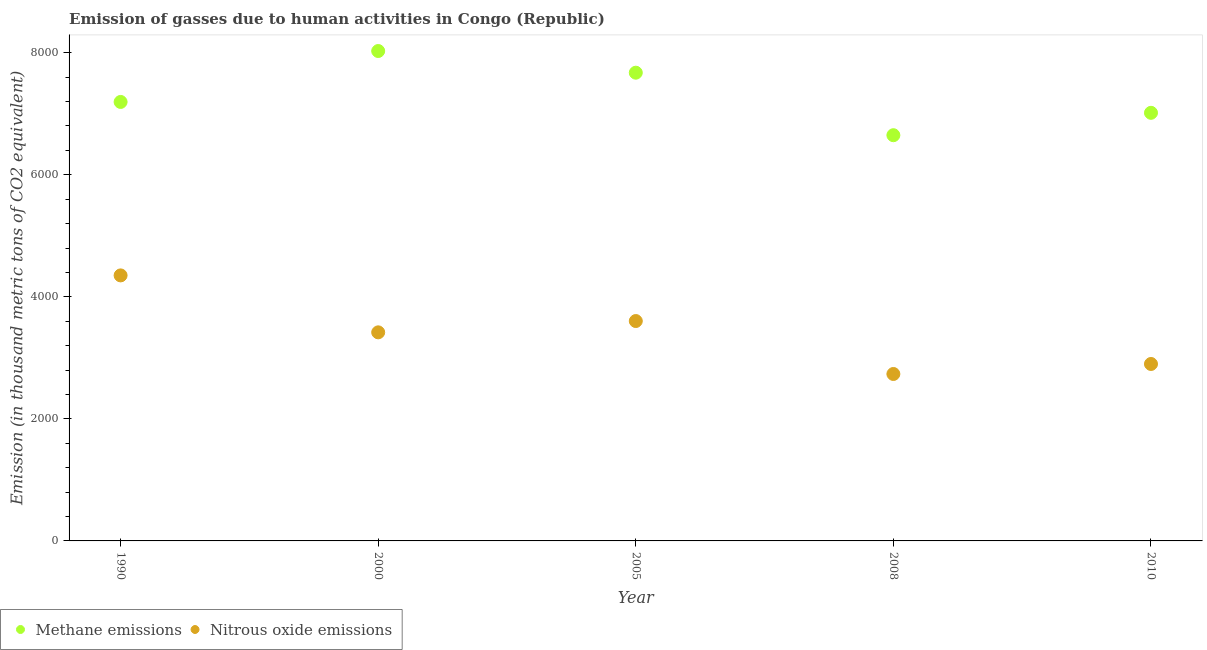How many different coloured dotlines are there?
Your answer should be very brief. 2. Is the number of dotlines equal to the number of legend labels?
Ensure brevity in your answer.  Yes. What is the amount of methane emissions in 2000?
Offer a very short reply. 8028.7. Across all years, what is the maximum amount of methane emissions?
Offer a terse response. 8028.7. Across all years, what is the minimum amount of methane emissions?
Your answer should be compact. 6649.1. In which year was the amount of methane emissions maximum?
Keep it short and to the point. 2000. What is the total amount of nitrous oxide emissions in the graph?
Provide a succinct answer. 1.70e+04. What is the difference between the amount of methane emissions in 2008 and that in 2010?
Provide a short and direct response. -366.9. What is the difference between the amount of nitrous oxide emissions in 2000 and the amount of methane emissions in 2008?
Offer a terse response. -3230.8. What is the average amount of nitrous oxide emissions per year?
Provide a short and direct response. 3401.78. In the year 2000, what is the difference between the amount of methane emissions and amount of nitrous oxide emissions?
Keep it short and to the point. 4610.4. What is the ratio of the amount of methane emissions in 2005 to that in 2010?
Your response must be concise. 1.09. Is the amount of methane emissions in 1990 less than that in 2005?
Provide a short and direct response. Yes. Is the difference between the amount of nitrous oxide emissions in 2008 and 2010 greater than the difference between the amount of methane emissions in 2008 and 2010?
Provide a succinct answer. Yes. What is the difference between the highest and the second highest amount of methane emissions?
Make the answer very short. 355.1. What is the difference between the highest and the lowest amount of nitrous oxide emissions?
Provide a short and direct response. 1615.7. Is the sum of the amount of nitrous oxide emissions in 2005 and 2008 greater than the maximum amount of methane emissions across all years?
Your answer should be very brief. No. Is the amount of methane emissions strictly less than the amount of nitrous oxide emissions over the years?
Provide a succinct answer. No. How many dotlines are there?
Your answer should be very brief. 2. Are the values on the major ticks of Y-axis written in scientific E-notation?
Offer a terse response. No. Does the graph contain any zero values?
Your answer should be compact. No. Does the graph contain grids?
Provide a succinct answer. No. Where does the legend appear in the graph?
Keep it short and to the point. Bottom left. How many legend labels are there?
Your answer should be compact. 2. What is the title of the graph?
Offer a very short reply. Emission of gasses due to human activities in Congo (Republic). Does "Exports of goods" appear as one of the legend labels in the graph?
Your response must be concise. No. What is the label or title of the Y-axis?
Offer a very short reply. Emission (in thousand metric tons of CO2 equivalent). What is the Emission (in thousand metric tons of CO2 equivalent) of Methane emissions in 1990?
Offer a terse response. 7194.2. What is the Emission (in thousand metric tons of CO2 equivalent) in Nitrous oxide emissions in 1990?
Provide a short and direct response. 4351.5. What is the Emission (in thousand metric tons of CO2 equivalent) in Methane emissions in 2000?
Give a very brief answer. 8028.7. What is the Emission (in thousand metric tons of CO2 equivalent) in Nitrous oxide emissions in 2000?
Your answer should be very brief. 3418.3. What is the Emission (in thousand metric tons of CO2 equivalent) in Methane emissions in 2005?
Give a very brief answer. 7673.6. What is the Emission (in thousand metric tons of CO2 equivalent) in Nitrous oxide emissions in 2005?
Offer a terse response. 3603.5. What is the Emission (in thousand metric tons of CO2 equivalent) of Methane emissions in 2008?
Your answer should be very brief. 6649.1. What is the Emission (in thousand metric tons of CO2 equivalent) of Nitrous oxide emissions in 2008?
Provide a short and direct response. 2735.8. What is the Emission (in thousand metric tons of CO2 equivalent) of Methane emissions in 2010?
Ensure brevity in your answer.  7016. What is the Emission (in thousand metric tons of CO2 equivalent) of Nitrous oxide emissions in 2010?
Your response must be concise. 2899.8. Across all years, what is the maximum Emission (in thousand metric tons of CO2 equivalent) in Methane emissions?
Your response must be concise. 8028.7. Across all years, what is the maximum Emission (in thousand metric tons of CO2 equivalent) in Nitrous oxide emissions?
Make the answer very short. 4351.5. Across all years, what is the minimum Emission (in thousand metric tons of CO2 equivalent) in Methane emissions?
Keep it short and to the point. 6649.1. Across all years, what is the minimum Emission (in thousand metric tons of CO2 equivalent) of Nitrous oxide emissions?
Provide a succinct answer. 2735.8. What is the total Emission (in thousand metric tons of CO2 equivalent) of Methane emissions in the graph?
Give a very brief answer. 3.66e+04. What is the total Emission (in thousand metric tons of CO2 equivalent) of Nitrous oxide emissions in the graph?
Make the answer very short. 1.70e+04. What is the difference between the Emission (in thousand metric tons of CO2 equivalent) of Methane emissions in 1990 and that in 2000?
Your answer should be very brief. -834.5. What is the difference between the Emission (in thousand metric tons of CO2 equivalent) in Nitrous oxide emissions in 1990 and that in 2000?
Your answer should be very brief. 933.2. What is the difference between the Emission (in thousand metric tons of CO2 equivalent) of Methane emissions in 1990 and that in 2005?
Your answer should be very brief. -479.4. What is the difference between the Emission (in thousand metric tons of CO2 equivalent) of Nitrous oxide emissions in 1990 and that in 2005?
Offer a terse response. 748. What is the difference between the Emission (in thousand metric tons of CO2 equivalent) of Methane emissions in 1990 and that in 2008?
Provide a succinct answer. 545.1. What is the difference between the Emission (in thousand metric tons of CO2 equivalent) of Nitrous oxide emissions in 1990 and that in 2008?
Your response must be concise. 1615.7. What is the difference between the Emission (in thousand metric tons of CO2 equivalent) of Methane emissions in 1990 and that in 2010?
Your answer should be compact. 178.2. What is the difference between the Emission (in thousand metric tons of CO2 equivalent) in Nitrous oxide emissions in 1990 and that in 2010?
Offer a very short reply. 1451.7. What is the difference between the Emission (in thousand metric tons of CO2 equivalent) in Methane emissions in 2000 and that in 2005?
Offer a very short reply. 355.1. What is the difference between the Emission (in thousand metric tons of CO2 equivalent) in Nitrous oxide emissions in 2000 and that in 2005?
Ensure brevity in your answer.  -185.2. What is the difference between the Emission (in thousand metric tons of CO2 equivalent) in Methane emissions in 2000 and that in 2008?
Offer a very short reply. 1379.6. What is the difference between the Emission (in thousand metric tons of CO2 equivalent) of Nitrous oxide emissions in 2000 and that in 2008?
Your answer should be very brief. 682.5. What is the difference between the Emission (in thousand metric tons of CO2 equivalent) in Methane emissions in 2000 and that in 2010?
Keep it short and to the point. 1012.7. What is the difference between the Emission (in thousand metric tons of CO2 equivalent) of Nitrous oxide emissions in 2000 and that in 2010?
Offer a terse response. 518.5. What is the difference between the Emission (in thousand metric tons of CO2 equivalent) in Methane emissions in 2005 and that in 2008?
Keep it short and to the point. 1024.5. What is the difference between the Emission (in thousand metric tons of CO2 equivalent) of Nitrous oxide emissions in 2005 and that in 2008?
Ensure brevity in your answer.  867.7. What is the difference between the Emission (in thousand metric tons of CO2 equivalent) in Methane emissions in 2005 and that in 2010?
Offer a very short reply. 657.6. What is the difference between the Emission (in thousand metric tons of CO2 equivalent) of Nitrous oxide emissions in 2005 and that in 2010?
Offer a very short reply. 703.7. What is the difference between the Emission (in thousand metric tons of CO2 equivalent) in Methane emissions in 2008 and that in 2010?
Provide a short and direct response. -366.9. What is the difference between the Emission (in thousand metric tons of CO2 equivalent) in Nitrous oxide emissions in 2008 and that in 2010?
Your response must be concise. -164. What is the difference between the Emission (in thousand metric tons of CO2 equivalent) of Methane emissions in 1990 and the Emission (in thousand metric tons of CO2 equivalent) of Nitrous oxide emissions in 2000?
Offer a very short reply. 3775.9. What is the difference between the Emission (in thousand metric tons of CO2 equivalent) in Methane emissions in 1990 and the Emission (in thousand metric tons of CO2 equivalent) in Nitrous oxide emissions in 2005?
Offer a very short reply. 3590.7. What is the difference between the Emission (in thousand metric tons of CO2 equivalent) of Methane emissions in 1990 and the Emission (in thousand metric tons of CO2 equivalent) of Nitrous oxide emissions in 2008?
Your answer should be compact. 4458.4. What is the difference between the Emission (in thousand metric tons of CO2 equivalent) in Methane emissions in 1990 and the Emission (in thousand metric tons of CO2 equivalent) in Nitrous oxide emissions in 2010?
Make the answer very short. 4294.4. What is the difference between the Emission (in thousand metric tons of CO2 equivalent) of Methane emissions in 2000 and the Emission (in thousand metric tons of CO2 equivalent) of Nitrous oxide emissions in 2005?
Offer a very short reply. 4425.2. What is the difference between the Emission (in thousand metric tons of CO2 equivalent) in Methane emissions in 2000 and the Emission (in thousand metric tons of CO2 equivalent) in Nitrous oxide emissions in 2008?
Your response must be concise. 5292.9. What is the difference between the Emission (in thousand metric tons of CO2 equivalent) in Methane emissions in 2000 and the Emission (in thousand metric tons of CO2 equivalent) in Nitrous oxide emissions in 2010?
Your response must be concise. 5128.9. What is the difference between the Emission (in thousand metric tons of CO2 equivalent) of Methane emissions in 2005 and the Emission (in thousand metric tons of CO2 equivalent) of Nitrous oxide emissions in 2008?
Provide a short and direct response. 4937.8. What is the difference between the Emission (in thousand metric tons of CO2 equivalent) in Methane emissions in 2005 and the Emission (in thousand metric tons of CO2 equivalent) in Nitrous oxide emissions in 2010?
Offer a terse response. 4773.8. What is the difference between the Emission (in thousand metric tons of CO2 equivalent) of Methane emissions in 2008 and the Emission (in thousand metric tons of CO2 equivalent) of Nitrous oxide emissions in 2010?
Ensure brevity in your answer.  3749.3. What is the average Emission (in thousand metric tons of CO2 equivalent) in Methane emissions per year?
Your answer should be compact. 7312.32. What is the average Emission (in thousand metric tons of CO2 equivalent) in Nitrous oxide emissions per year?
Provide a short and direct response. 3401.78. In the year 1990, what is the difference between the Emission (in thousand metric tons of CO2 equivalent) of Methane emissions and Emission (in thousand metric tons of CO2 equivalent) of Nitrous oxide emissions?
Provide a succinct answer. 2842.7. In the year 2000, what is the difference between the Emission (in thousand metric tons of CO2 equivalent) in Methane emissions and Emission (in thousand metric tons of CO2 equivalent) in Nitrous oxide emissions?
Your answer should be very brief. 4610.4. In the year 2005, what is the difference between the Emission (in thousand metric tons of CO2 equivalent) in Methane emissions and Emission (in thousand metric tons of CO2 equivalent) in Nitrous oxide emissions?
Your response must be concise. 4070.1. In the year 2008, what is the difference between the Emission (in thousand metric tons of CO2 equivalent) of Methane emissions and Emission (in thousand metric tons of CO2 equivalent) of Nitrous oxide emissions?
Provide a short and direct response. 3913.3. In the year 2010, what is the difference between the Emission (in thousand metric tons of CO2 equivalent) of Methane emissions and Emission (in thousand metric tons of CO2 equivalent) of Nitrous oxide emissions?
Offer a very short reply. 4116.2. What is the ratio of the Emission (in thousand metric tons of CO2 equivalent) in Methane emissions in 1990 to that in 2000?
Provide a short and direct response. 0.9. What is the ratio of the Emission (in thousand metric tons of CO2 equivalent) of Nitrous oxide emissions in 1990 to that in 2000?
Offer a terse response. 1.27. What is the ratio of the Emission (in thousand metric tons of CO2 equivalent) of Methane emissions in 1990 to that in 2005?
Offer a very short reply. 0.94. What is the ratio of the Emission (in thousand metric tons of CO2 equivalent) of Nitrous oxide emissions in 1990 to that in 2005?
Offer a very short reply. 1.21. What is the ratio of the Emission (in thousand metric tons of CO2 equivalent) in Methane emissions in 1990 to that in 2008?
Your response must be concise. 1.08. What is the ratio of the Emission (in thousand metric tons of CO2 equivalent) of Nitrous oxide emissions in 1990 to that in 2008?
Offer a very short reply. 1.59. What is the ratio of the Emission (in thousand metric tons of CO2 equivalent) of Methane emissions in 1990 to that in 2010?
Your answer should be compact. 1.03. What is the ratio of the Emission (in thousand metric tons of CO2 equivalent) in Nitrous oxide emissions in 1990 to that in 2010?
Ensure brevity in your answer.  1.5. What is the ratio of the Emission (in thousand metric tons of CO2 equivalent) in Methane emissions in 2000 to that in 2005?
Provide a short and direct response. 1.05. What is the ratio of the Emission (in thousand metric tons of CO2 equivalent) in Nitrous oxide emissions in 2000 to that in 2005?
Give a very brief answer. 0.95. What is the ratio of the Emission (in thousand metric tons of CO2 equivalent) in Methane emissions in 2000 to that in 2008?
Your answer should be compact. 1.21. What is the ratio of the Emission (in thousand metric tons of CO2 equivalent) of Nitrous oxide emissions in 2000 to that in 2008?
Your response must be concise. 1.25. What is the ratio of the Emission (in thousand metric tons of CO2 equivalent) of Methane emissions in 2000 to that in 2010?
Give a very brief answer. 1.14. What is the ratio of the Emission (in thousand metric tons of CO2 equivalent) of Nitrous oxide emissions in 2000 to that in 2010?
Provide a short and direct response. 1.18. What is the ratio of the Emission (in thousand metric tons of CO2 equivalent) of Methane emissions in 2005 to that in 2008?
Give a very brief answer. 1.15. What is the ratio of the Emission (in thousand metric tons of CO2 equivalent) in Nitrous oxide emissions in 2005 to that in 2008?
Provide a short and direct response. 1.32. What is the ratio of the Emission (in thousand metric tons of CO2 equivalent) in Methane emissions in 2005 to that in 2010?
Your response must be concise. 1.09. What is the ratio of the Emission (in thousand metric tons of CO2 equivalent) of Nitrous oxide emissions in 2005 to that in 2010?
Keep it short and to the point. 1.24. What is the ratio of the Emission (in thousand metric tons of CO2 equivalent) of Methane emissions in 2008 to that in 2010?
Make the answer very short. 0.95. What is the ratio of the Emission (in thousand metric tons of CO2 equivalent) of Nitrous oxide emissions in 2008 to that in 2010?
Your answer should be very brief. 0.94. What is the difference between the highest and the second highest Emission (in thousand metric tons of CO2 equivalent) of Methane emissions?
Provide a succinct answer. 355.1. What is the difference between the highest and the second highest Emission (in thousand metric tons of CO2 equivalent) in Nitrous oxide emissions?
Your answer should be very brief. 748. What is the difference between the highest and the lowest Emission (in thousand metric tons of CO2 equivalent) of Methane emissions?
Provide a succinct answer. 1379.6. What is the difference between the highest and the lowest Emission (in thousand metric tons of CO2 equivalent) of Nitrous oxide emissions?
Give a very brief answer. 1615.7. 